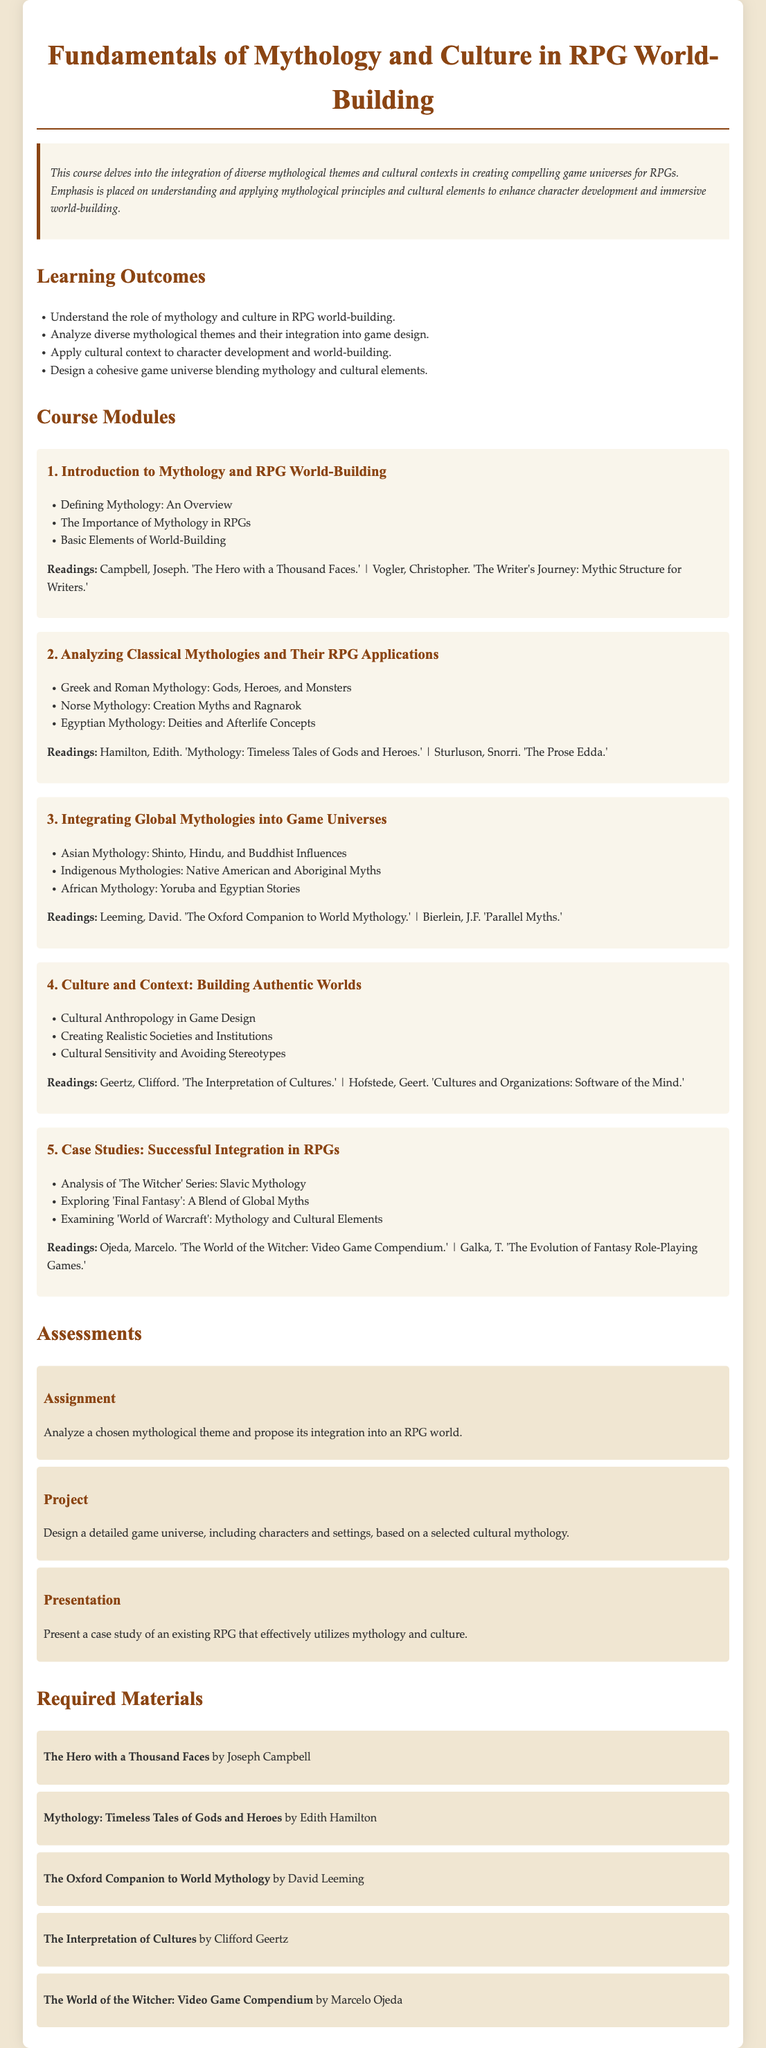what is the title of the course? The title is listed at the beginning of the document.
Answer: Fundamentals of Mythology and Culture in RPG World-Building what is the main focus of the course? The course description highlights the integration of diverse mythological themes and cultural contexts.
Answer: Creating compelling game universes who is the author of 'The Hero with a Thousand Faces'? This information is provided in the required materials section.
Answer: Joseph Campbell how many course modules are there? The number of course modules can be counted in the document.
Answer: Five what is one cultural aspect emphasized in the course? This information can be found in the 'Culture and Context' module.
Answer: Cultural Sensitivity and Avoiding Stereotypes what kind of project is assigned in the assessments? The project details are outlined in the assessments section.
Answer: Design a detailed game universe which mythology is associated with 'The Witcher' series in case studies? The case studies section specifies this information.
Answer: Slavic Mythology what is one reading for the module on global mythologies? This information is found in the readings section of the corresponding module.
Answer: The Oxford Companion to World Mythology how are mythological elements applied in RPGs? This is inferred from the learning outcomes section describing applications.
Answer: Analyze diverse mythological themes and their integration into game design 